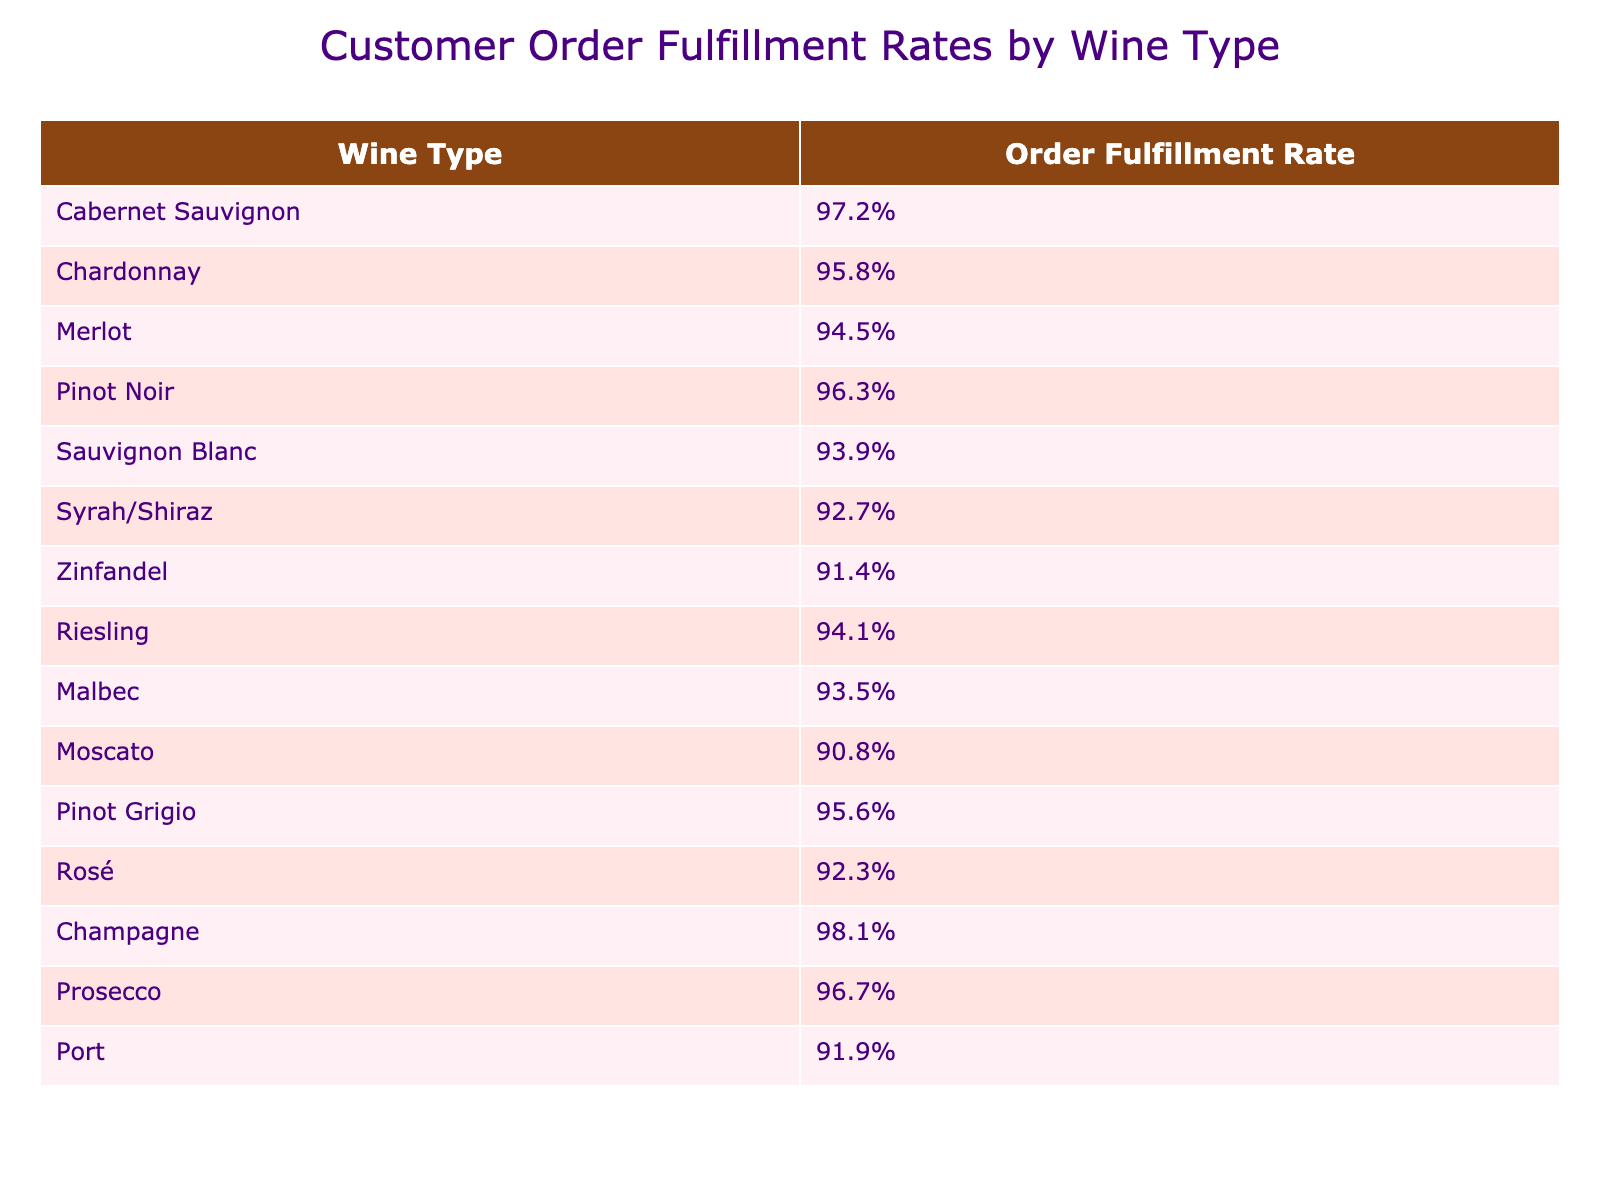What is the highest order fulfillment rate among the wine types? The table shows the order fulfillment rates for each wine type. The highest value listed is 98.1% for Champagne.
Answer: 98.1% Which wine type has the lowest order fulfillment rate? By looking at the table, the lowest order fulfillment rate is 90.8%, which belongs to Moscato.
Answer: Moscato What is the average order fulfillment rate for all wine types? To find the average, we sum all the order fulfillment rates: (97.2 + 95.8 + 94.5 + 96.3 + 93.9 + 92.7 + 91.4 + 94.1 + 93.5 + 90.8 + 95.6 + 92.3 + 98.1 + 96.7 + 91.9) = 1,427.5. We then divide by the number of wines (15): 1,427.5 / 15 = 95.17%.
Answer: 95.17% Is the order fulfillment rate for Pinot Noir greater than that for Zinfandel? The order fulfillment rate for Pinot Noir is 96.3%, while for Zinfandel it is 91.4%. Since 96.3% is greater than 91.4%, the statement is true.
Answer: Yes How many wine types have an order fulfillment rate above 95%? By examining the table, the wine types with rates above 95% are: Cabernet Sauvignon, Chardonnay, Pinot Noir, Pinot Grigio, Champagne, and Prosecco. This totals to 6 wine types.
Answer: 6 What is the difference in order fulfillment rates between Cabernet Sauvignon and Zinfandel? The order fulfillment rate for Cabernet Sauvignon is 97.2% and for Zinfandel it is 91.4%. The difference is calculated as 97.2% - 91.4% = 5.8%.
Answer: 5.8% Which wine type has an order fulfillment rate closest to the average of 95.17%? The average is 95.17%. The wine types with rates closest to this are Chardonnay (95.8%) and Pinot Grigio (95.6%), closest to the average when rounding.
Answer: Chardonnay and Pinot Grigio Are there more wine types with order fulfillment rates below or above 93%? There are 6 wine types below 93% (Sauvignon Blanc, Syrah/Shiraz, Zinfandel, Moscato, and Port) and 9 above 93% (Cabernet Sauvignon, Chardonnay, Merlot, Pinot Noir, Riesling, Malbec, Pinot Grigio, Rosé, Champagne, and Prosecco). Therefore, there are more wine types above 93%.
Answer: Above 93% What percentage of wine types have an order fulfillment rate above 92%? There are 12 wine types with rates above 92% out of 15 total wine types: (12 / 15) * 100 = 80%.
Answer: 80% 